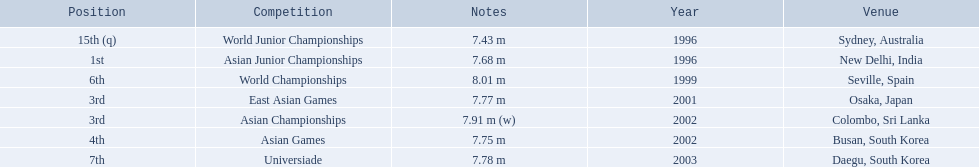What are all of the competitions? World Junior Championships, Asian Junior Championships, World Championships, East Asian Games, Asian Championships, Asian Games, Universiade. What was his positions in these competitions? 15th (q), 1st, 6th, 3rd, 3rd, 4th, 7th. Parse the full table in json format. {'header': ['Position', 'Competition', 'Notes', 'Year', 'Venue'], 'rows': [['15th (q)', 'World Junior Championships', '7.43 m', '1996', 'Sydney, Australia'], ['1st', 'Asian Junior Championships', '7.68 m', '1996', 'New Delhi, India'], ['6th', 'World Championships', '8.01 m', '1999', 'Seville, Spain'], ['3rd', 'East Asian Games', '7.77 m', '2001', 'Osaka, Japan'], ['3rd', 'Asian Championships', '7.91 m (w)', '2002', 'Colombo, Sri Lanka'], ['4th', 'Asian Games', '7.75 m', '2002', 'Busan, South Korea'], ['7th', 'Universiade', '7.78 m', '2003', 'Daegu, South Korea']]} And during which competition did he reach 1st place? Asian Junior Championships. 